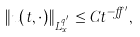<formula> <loc_0><loc_0><loc_500><loc_500>\| u ( t , \cdot ) \| _ { L _ { x } ^ { q ^ { \prime } } } \leq C t ^ { - \alpha ^ { \prime } } ,</formula> 